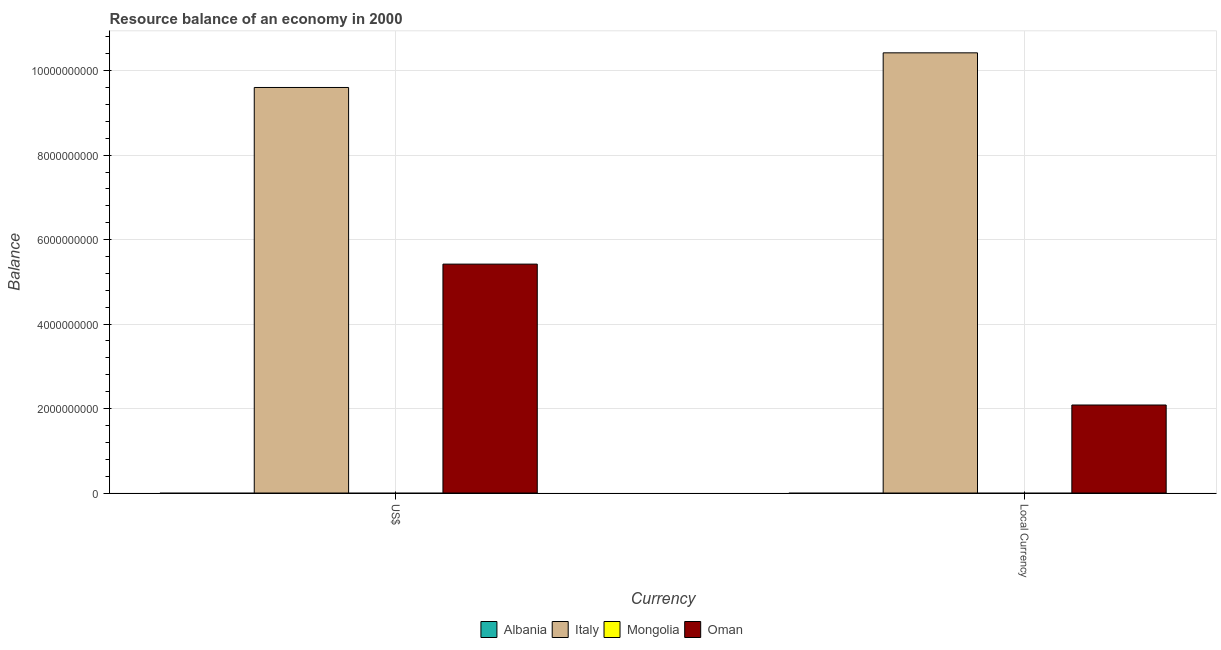How many different coloured bars are there?
Your response must be concise. 2. How many groups of bars are there?
Ensure brevity in your answer.  2. Are the number of bars per tick equal to the number of legend labels?
Your answer should be very brief. No. How many bars are there on the 2nd tick from the right?
Keep it short and to the point. 2. What is the label of the 1st group of bars from the left?
Your answer should be compact. US$. Across all countries, what is the maximum resource balance in constant us$?
Keep it short and to the point. 1.04e+1. What is the total resource balance in constant us$ in the graph?
Offer a very short reply. 1.25e+1. What is the difference between the resource balance in constant us$ in Oman and the resource balance in us$ in Albania?
Your response must be concise. 2.08e+09. What is the average resource balance in us$ per country?
Your response must be concise. 3.76e+09. What is the difference between the resource balance in us$ and resource balance in constant us$ in Italy?
Your response must be concise. -8.20e+08. What is the ratio of the resource balance in constant us$ in Oman to that in Italy?
Make the answer very short. 0.2. In how many countries, is the resource balance in constant us$ greater than the average resource balance in constant us$ taken over all countries?
Provide a succinct answer. 1. How many bars are there?
Provide a short and direct response. 4. Are all the bars in the graph horizontal?
Give a very brief answer. No. How many countries are there in the graph?
Ensure brevity in your answer.  4. Does the graph contain any zero values?
Give a very brief answer. Yes. How are the legend labels stacked?
Give a very brief answer. Horizontal. What is the title of the graph?
Provide a succinct answer. Resource balance of an economy in 2000. What is the label or title of the X-axis?
Make the answer very short. Currency. What is the label or title of the Y-axis?
Your response must be concise. Balance. What is the Balance of Albania in US$?
Offer a very short reply. 0. What is the Balance in Italy in US$?
Your response must be concise. 9.60e+09. What is the Balance in Mongolia in US$?
Make the answer very short. 0. What is the Balance in Oman in US$?
Provide a succinct answer. 5.42e+09. What is the Balance in Albania in Local Currency?
Your response must be concise. 0. What is the Balance of Italy in Local Currency?
Your response must be concise. 1.04e+1. What is the Balance of Oman in Local Currency?
Keep it short and to the point. 2.08e+09. Across all Currency, what is the maximum Balance in Italy?
Ensure brevity in your answer.  1.04e+1. Across all Currency, what is the maximum Balance in Oman?
Offer a very short reply. 5.42e+09. Across all Currency, what is the minimum Balance of Italy?
Your answer should be very brief. 9.60e+09. Across all Currency, what is the minimum Balance in Oman?
Your answer should be compact. 2.08e+09. What is the total Balance of Italy in the graph?
Your answer should be compact. 2.00e+1. What is the total Balance in Mongolia in the graph?
Provide a succinct answer. 0. What is the total Balance of Oman in the graph?
Your response must be concise. 7.50e+09. What is the difference between the Balance of Italy in US$ and that in Local Currency?
Ensure brevity in your answer.  -8.20e+08. What is the difference between the Balance of Oman in US$ and that in Local Currency?
Provide a short and direct response. 3.34e+09. What is the difference between the Balance in Italy in US$ and the Balance in Oman in Local Currency?
Provide a short and direct response. 7.52e+09. What is the average Balance in Albania per Currency?
Provide a succinct answer. 0. What is the average Balance in Italy per Currency?
Your answer should be compact. 1.00e+1. What is the average Balance in Mongolia per Currency?
Give a very brief answer. 0. What is the average Balance in Oman per Currency?
Keep it short and to the point. 3.75e+09. What is the difference between the Balance in Italy and Balance in Oman in US$?
Ensure brevity in your answer.  4.18e+09. What is the difference between the Balance in Italy and Balance in Oman in Local Currency?
Offer a terse response. 8.34e+09. What is the ratio of the Balance in Italy in US$ to that in Local Currency?
Offer a very short reply. 0.92. What is the ratio of the Balance of Oman in US$ to that in Local Currency?
Offer a terse response. 2.6. What is the difference between the highest and the second highest Balance in Italy?
Ensure brevity in your answer.  8.20e+08. What is the difference between the highest and the second highest Balance in Oman?
Your answer should be very brief. 3.34e+09. What is the difference between the highest and the lowest Balance of Italy?
Offer a terse response. 8.20e+08. What is the difference between the highest and the lowest Balance in Oman?
Keep it short and to the point. 3.34e+09. 